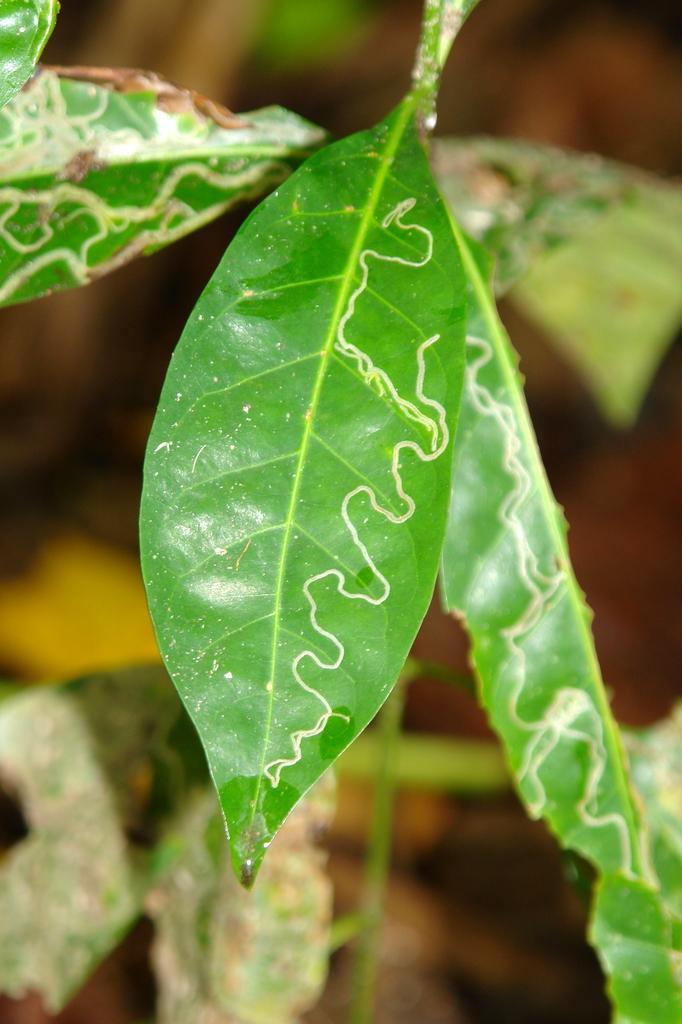How would you summarize this image in a sentence or two? In this image we can see some leaves and there are some brown color lines. 